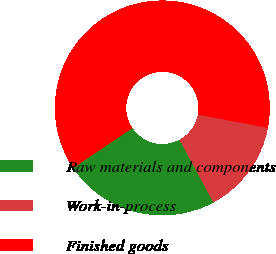<chart> <loc_0><loc_0><loc_500><loc_500><pie_chart><fcel>Raw materials and components<fcel>Work-in-process<fcel>Finished goods<nl><fcel>23.46%<fcel>14.14%<fcel>62.4%<nl></chart> 